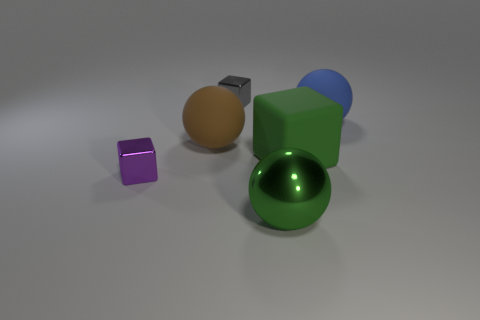Is there a tiny gray metal object left of the tiny block behind the purple metal object?
Ensure brevity in your answer.  No. Is the number of large blue matte things that are in front of the big green matte thing less than the number of big green rubber objects?
Your response must be concise. Yes. Does the cube that is to the right of the green metallic thing have the same material as the blue thing?
Provide a succinct answer. Yes. The big cube that is made of the same material as the large brown sphere is what color?
Make the answer very short. Green. Are there fewer large spheres behind the gray shiny thing than purple metal objects that are on the right side of the green metallic sphere?
Make the answer very short. No. There is a matte ball left of the green shiny sphere; is its color the same as the metallic cube that is behind the blue rubber object?
Offer a terse response. No. Are there any green objects that have the same material as the big blue object?
Provide a succinct answer. Yes. There is a metallic thing on the right side of the tiny thing behind the large green block; how big is it?
Keep it short and to the point. Large. Are there more purple cubes than small yellow matte things?
Offer a terse response. Yes. There is a matte ball that is to the right of the green rubber object; is its size the same as the purple metal cube?
Make the answer very short. No. 